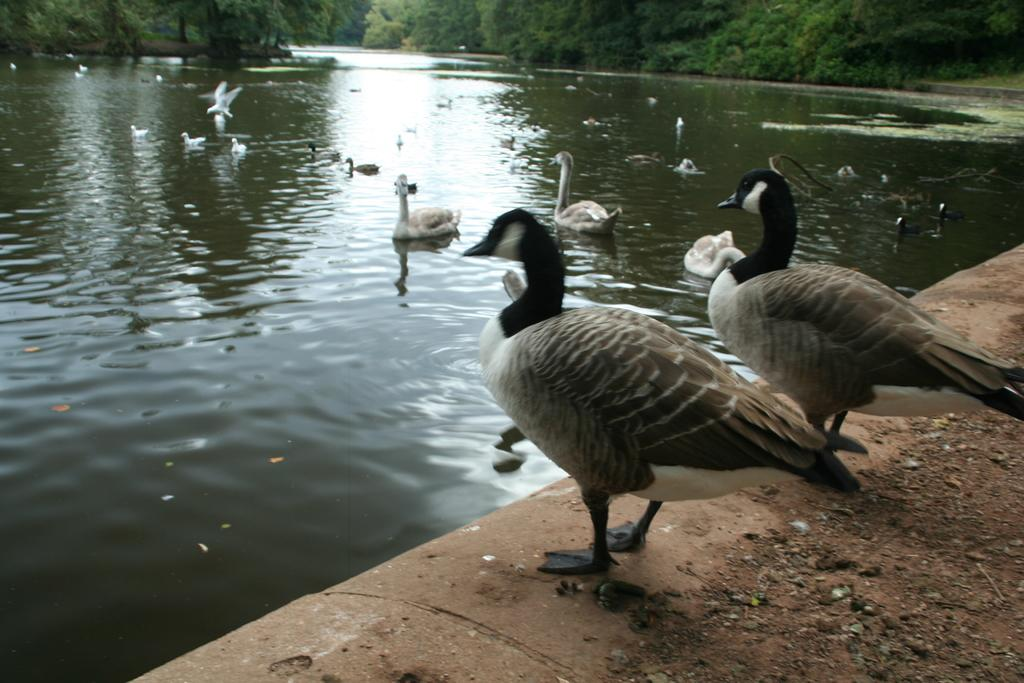What type of animals can be seen in the image? There are many birds in the water in the image. What is the primary element in which the birds are situated? The birds are situated in water. What type of terrain is visible in the image? There is grass, trees, and sand visible in the image. Can you describe the positioning of two birds in the image? Yes, there are two birds next to each other in the image. What is the health condition of the sister in the image? There is no sister present in the image, so it is not possible to determine her health condition. 